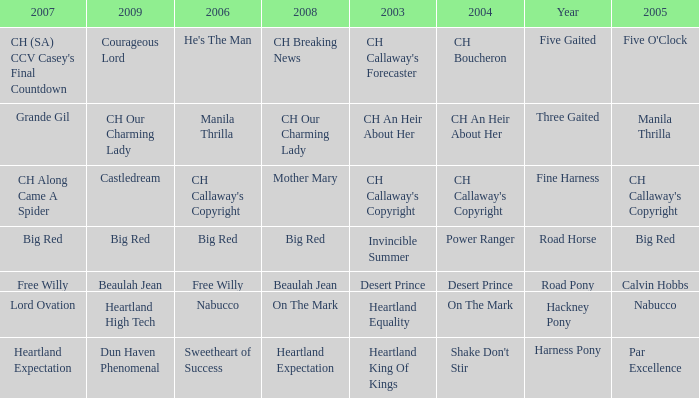What year is the 2004 shake don't stir? Harness Pony. 